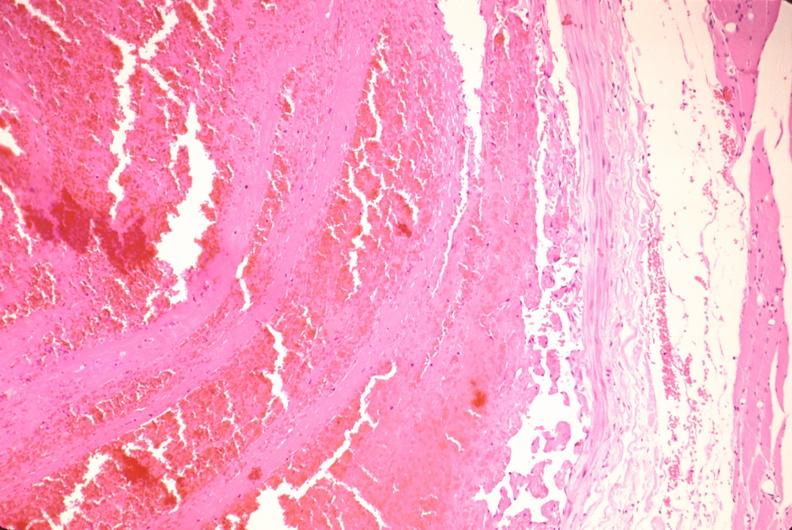s vasculature present?
Answer the question using a single word or phrase. Yes 